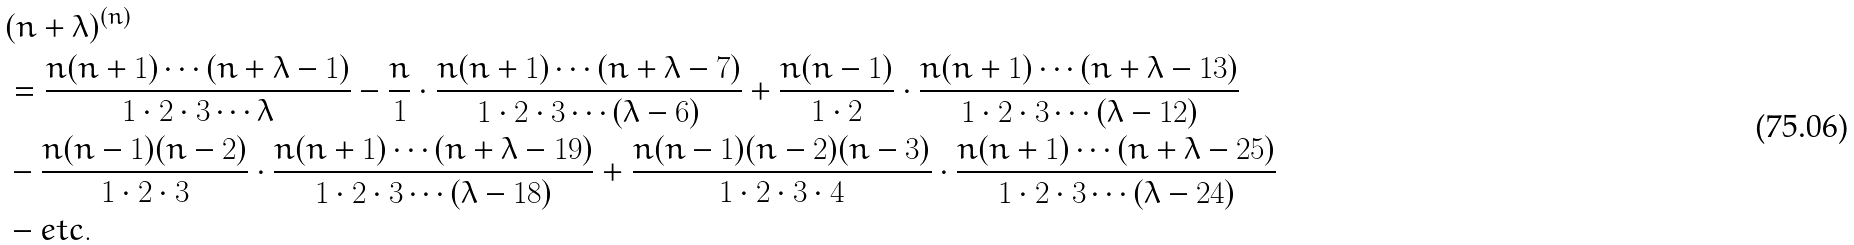Convert formula to latex. <formula><loc_0><loc_0><loc_500><loc_500>& ( n + \lambda ) ^ { ( n ) } \\ & = \frac { n ( n + 1 ) \cdots ( n + \lambda - 1 ) } { 1 \cdot 2 \cdot 3 \cdots \lambda } - \frac { n } { 1 } \cdot \frac { n ( n + 1 ) \cdots ( n + \lambda - 7 ) } { 1 \cdot 2 \cdot 3 \cdots ( \lambda - 6 ) } + \frac { n ( n - 1 ) } { 1 \cdot 2 } \cdot \frac { n ( n + 1 ) \cdots ( n + \lambda - 1 3 ) } { 1 \cdot 2 \cdot 3 \cdots ( \lambda - 1 2 ) } \\ & - \frac { n ( n - 1 ) ( n - 2 ) } { 1 \cdot 2 \cdot 3 } \cdot \frac { n ( n + 1 ) \cdots ( n + \lambda - 1 9 ) } { 1 \cdot 2 \cdot 3 \cdots ( \lambda - 1 8 ) } + \frac { n ( n - 1 ) ( n - 2 ) ( n - 3 ) } { 1 \cdot 2 \cdot 3 \cdot 4 } \cdot \frac { n ( n + 1 ) \cdots ( n + \lambda - 2 5 ) } { 1 \cdot 2 \cdot 3 \cdots ( \lambda - 2 4 ) } \\ & - e t c .</formula> 